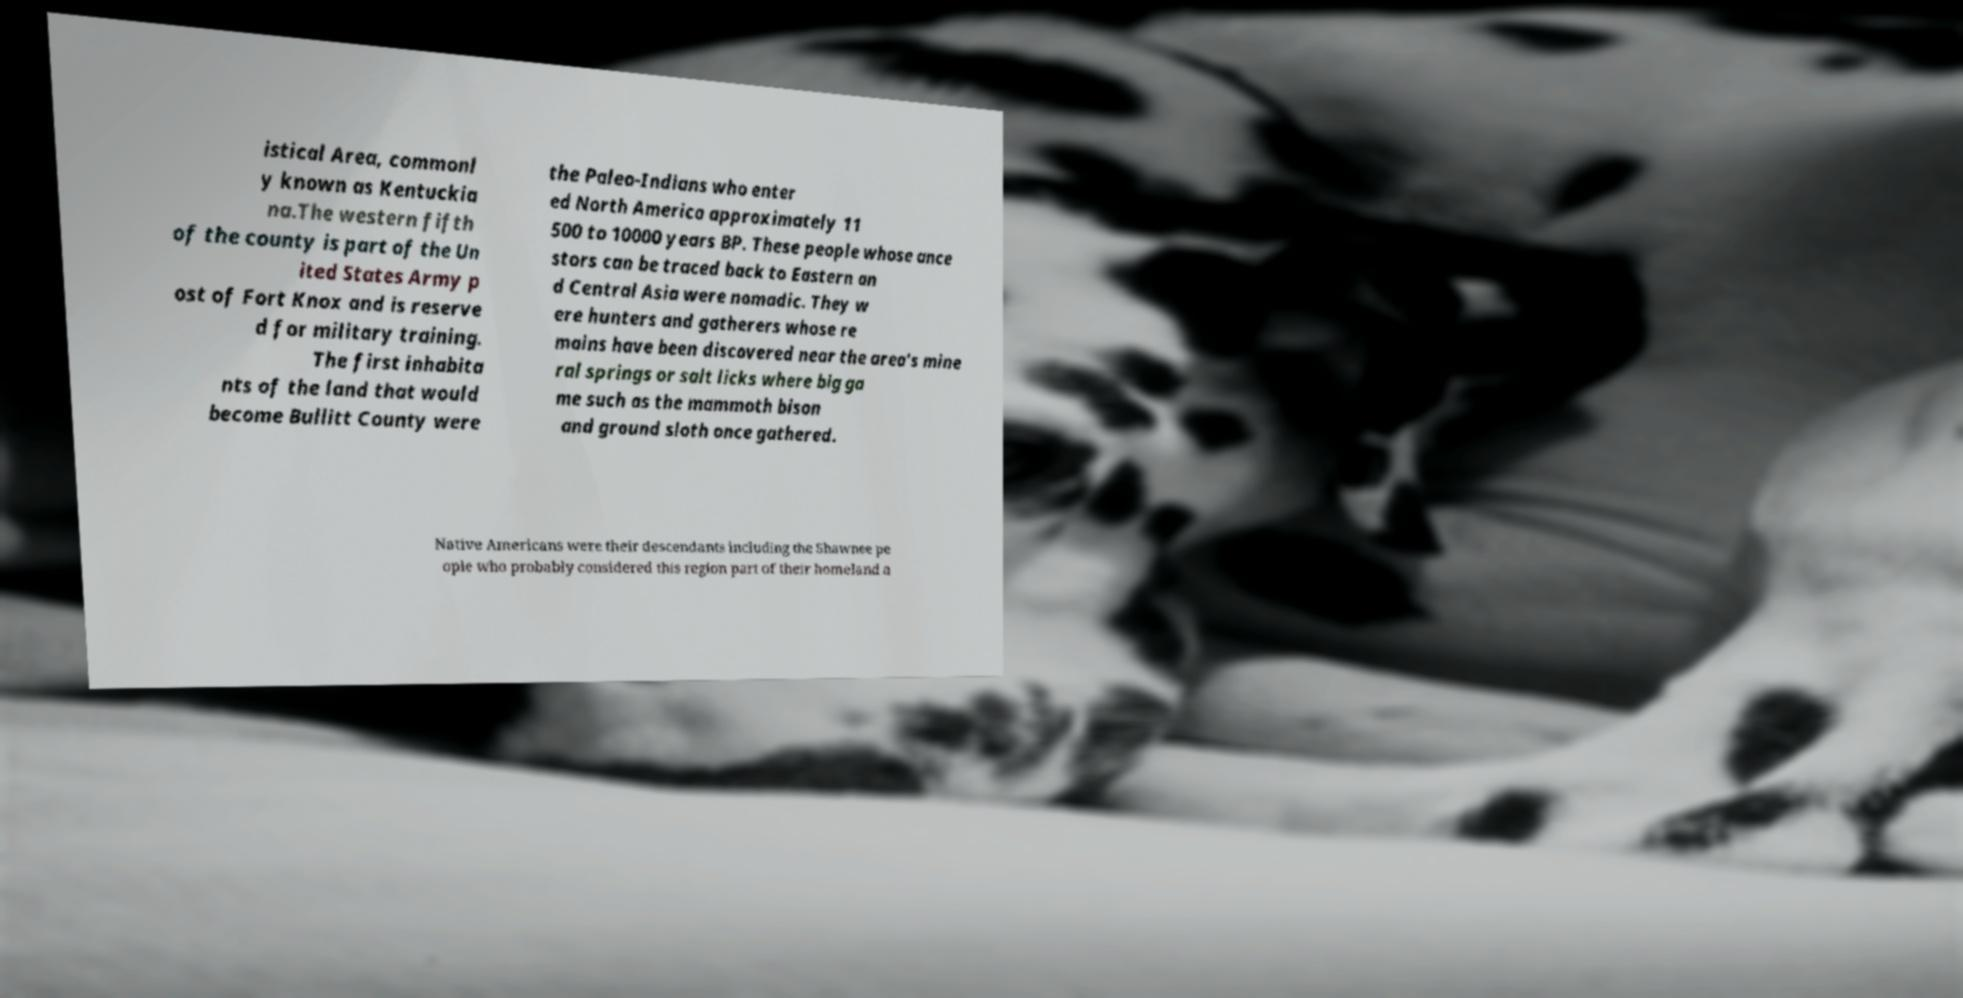Please read and relay the text visible in this image. What does it say? istical Area, commonl y known as Kentuckia na.The western fifth of the county is part of the Un ited States Army p ost of Fort Knox and is reserve d for military training. The first inhabita nts of the land that would become Bullitt County were the Paleo-Indians who enter ed North America approximately 11 500 to 10000 years BP. These people whose ance stors can be traced back to Eastern an d Central Asia were nomadic. They w ere hunters and gatherers whose re mains have been discovered near the area's mine ral springs or salt licks where big ga me such as the mammoth bison and ground sloth once gathered. Native Americans were their descendants including the Shawnee pe ople who probably considered this region part of their homeland a 